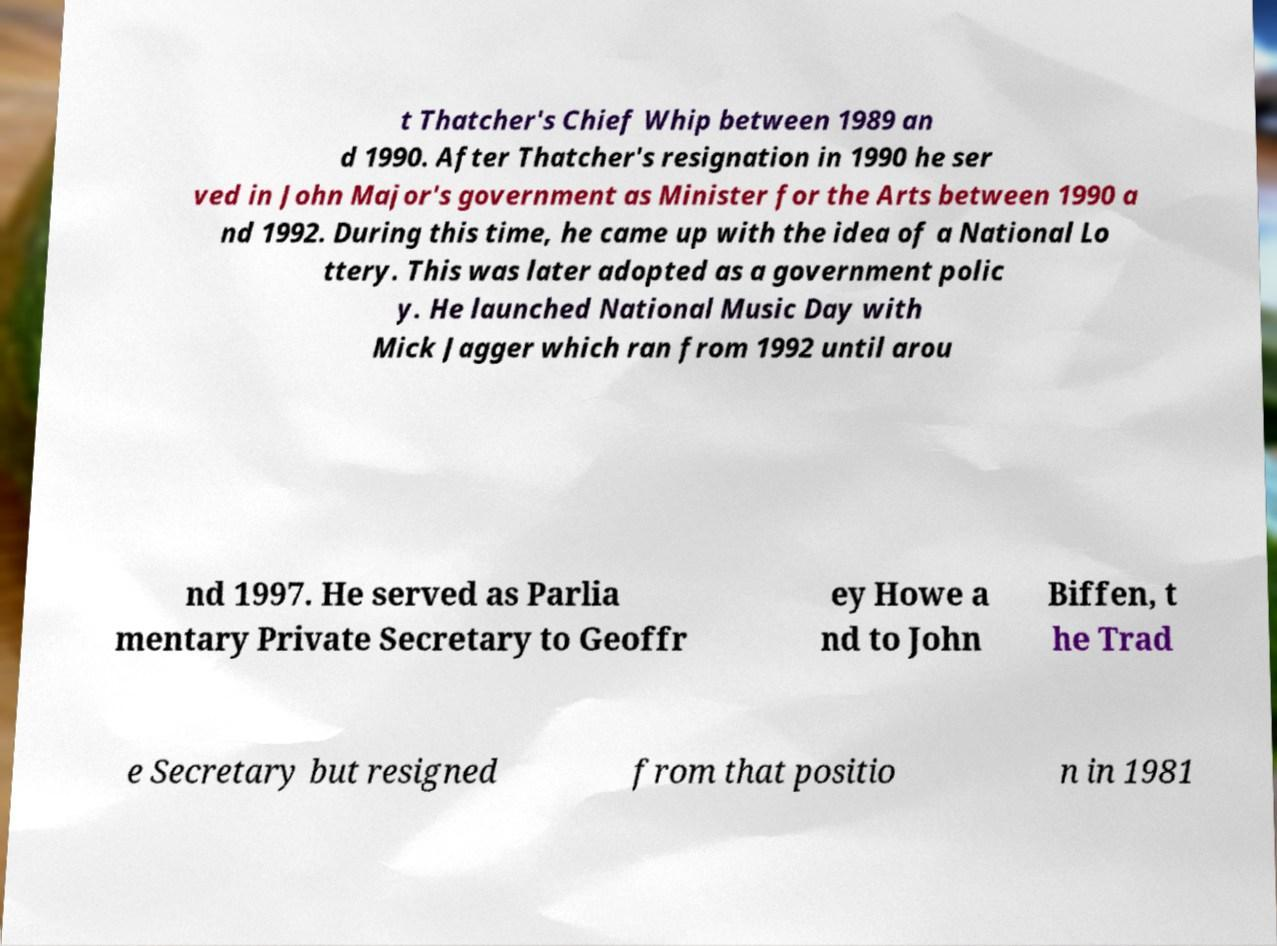Can you read and provide the text displayed in the image?This photo seems to have some interesting text. Can you extract and type it out for me? t Thatcher's Chief Whip between 1989 an d 1990. After Thatcher's resignation in 1990 he ser ved in John Major's government as Minister for the Arts between 1990 a nd 1992. During this time, he came up with the idea of a National Lo ttery. This was later adopted as a government polic y. He launched National Music Day with Mick Jagger which ran from 1992 until arou nd 1997. He served as Parlia mentary Private Secretary to Geoffr ey Howe a nd to John Biffen, t he Trad e Secretary but resigned from that positio n in 1981 